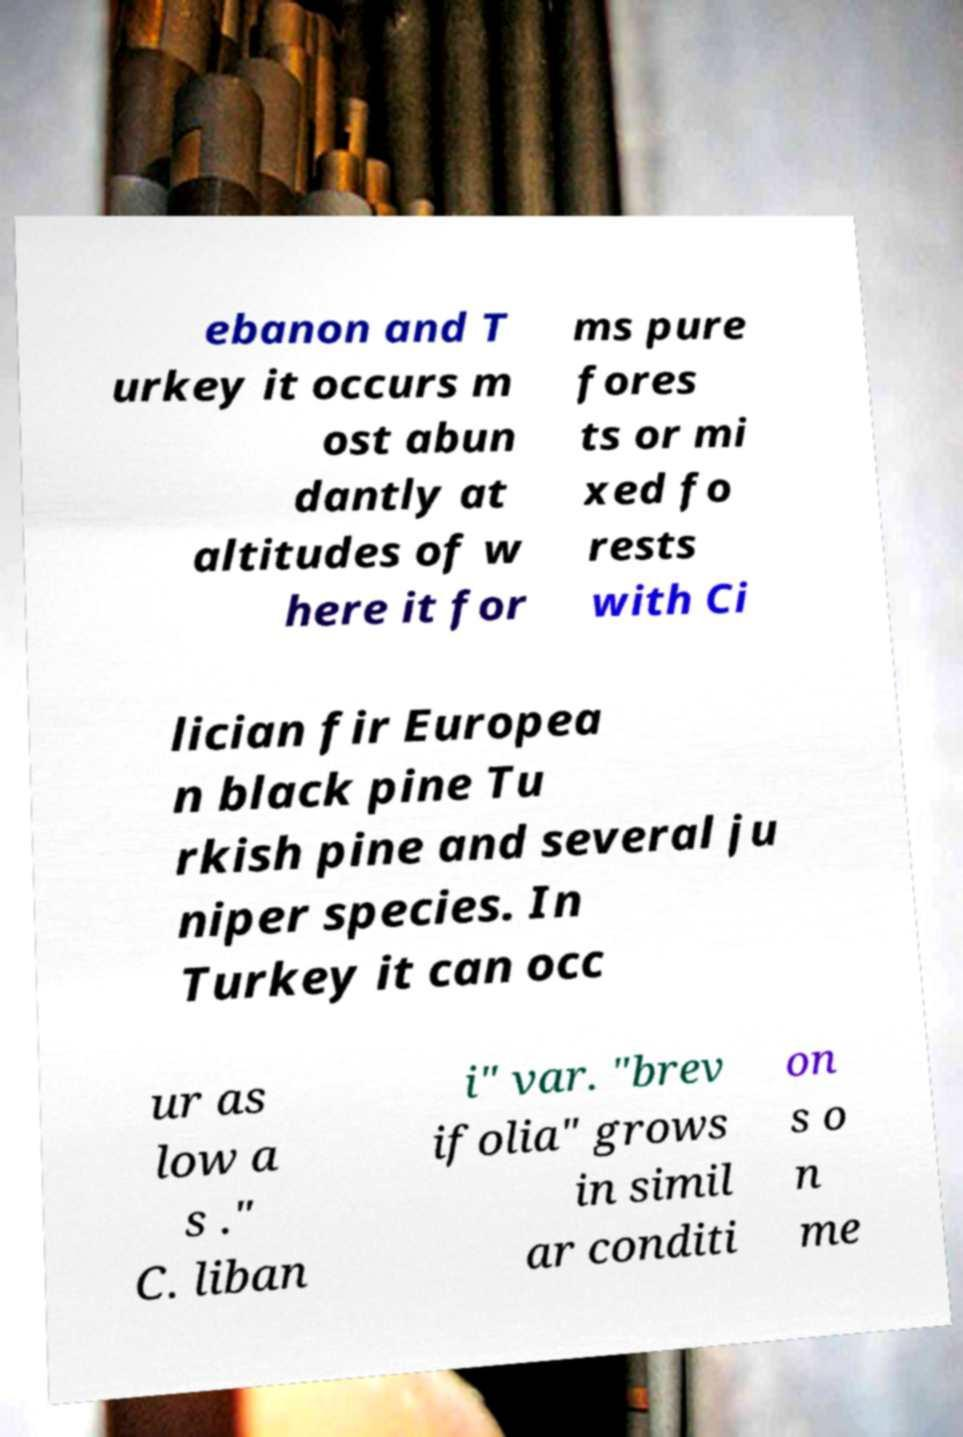Can you accurately transcribe the text from the provided image for me? ebanon and T urkey it occurs m ost abun dantly at altitudes of w here it for ms pure fores ts or mi xed fo rests with Ci lician fir Europea n black pine Tu rkish pine and several ju niper species. In Turkey it can occ ur as low a s ." C. liban i" var. "brev ifolia" grows in simil ar conditi on s o n me 